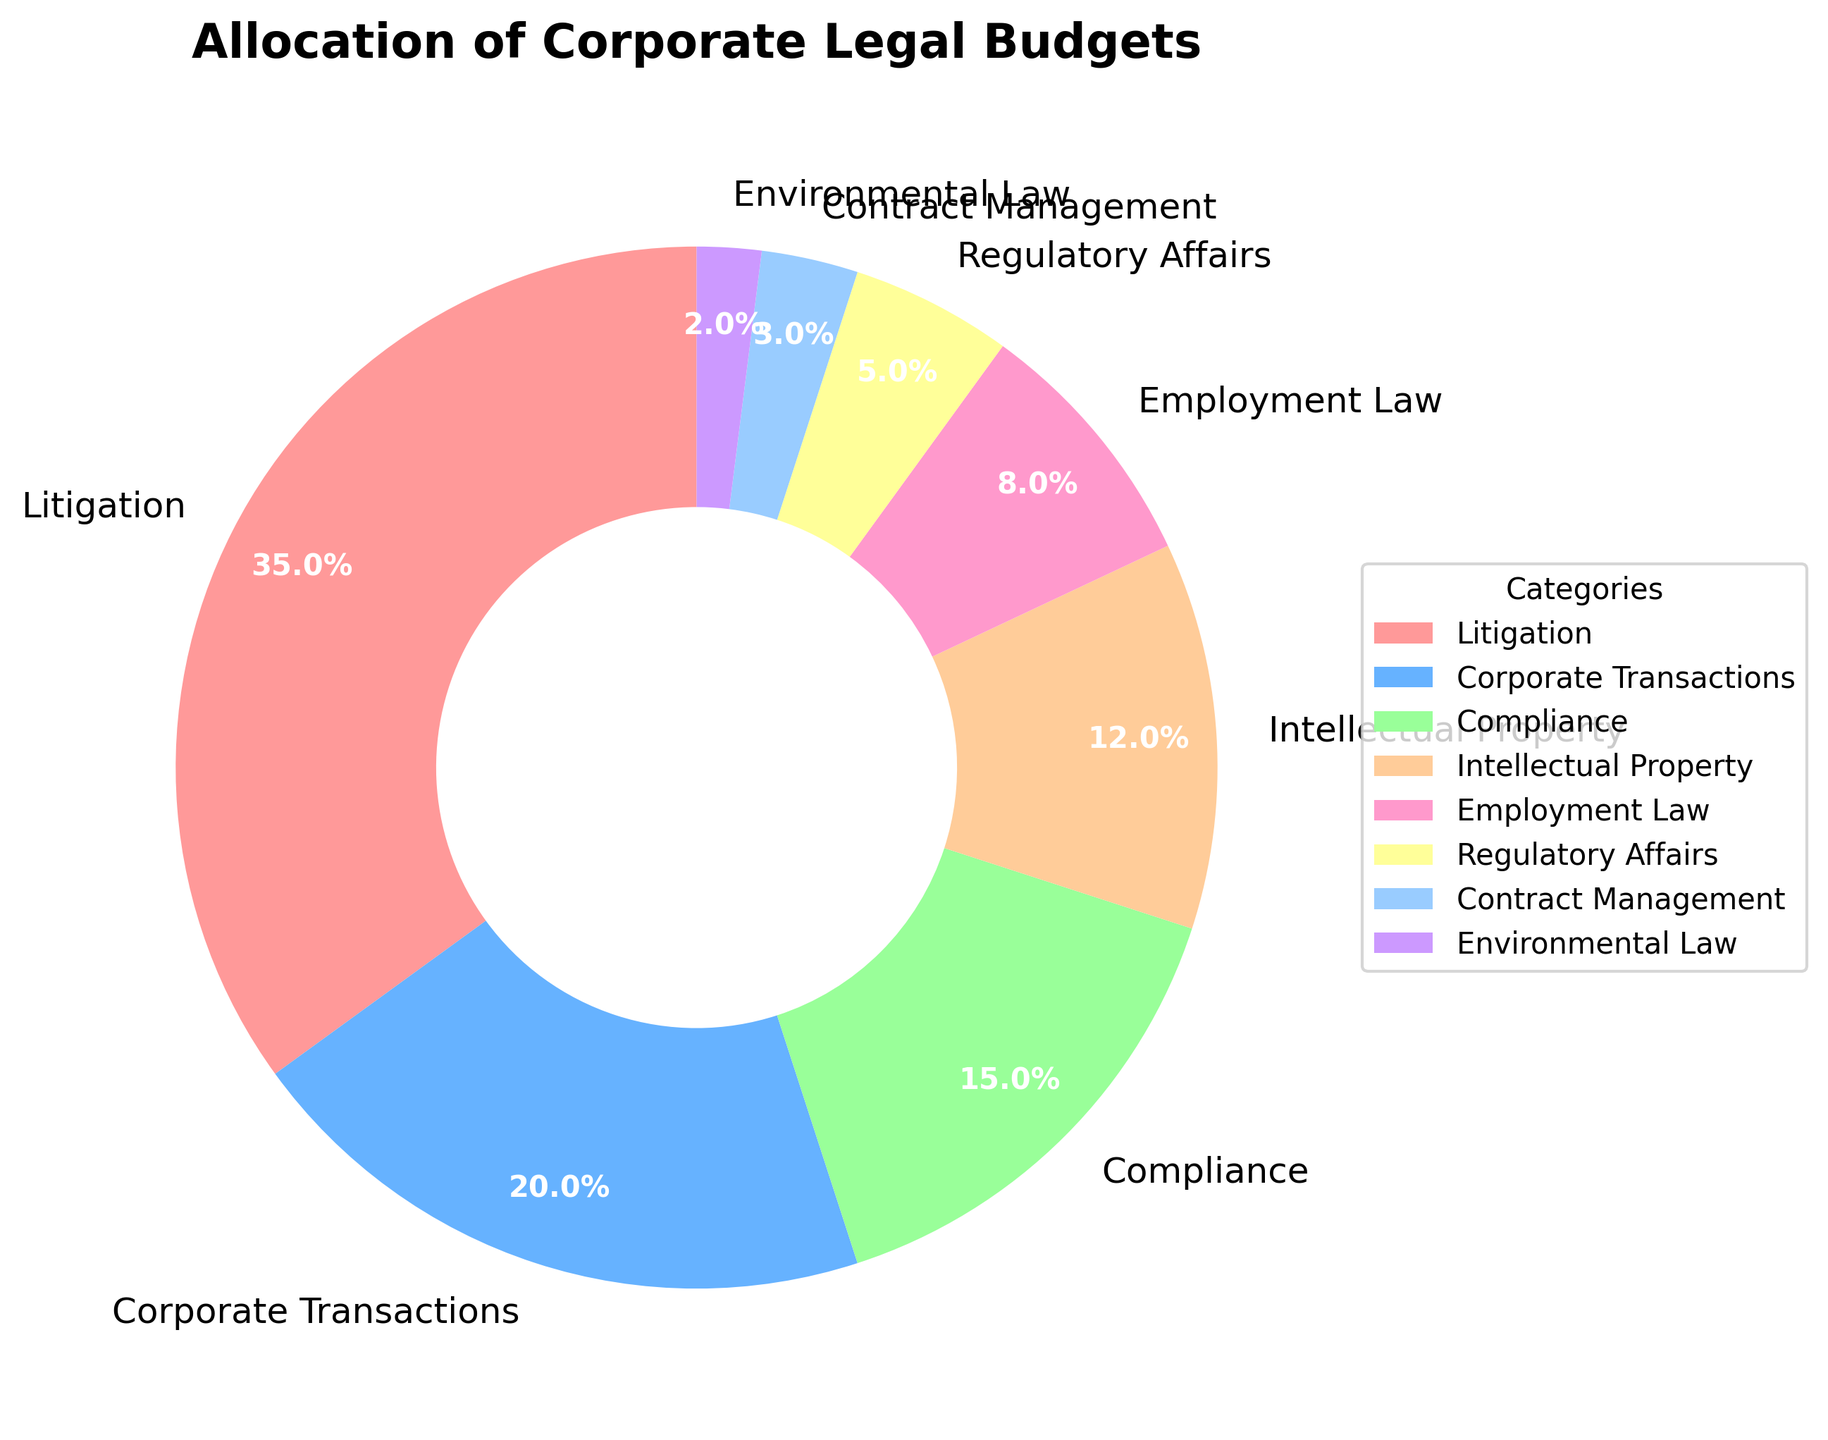What's the total percentage allocated to Litigation and Corporate Transactions together? To determine the total percentage allocated to Litigation and Corporate Transactions, add the percentages of both categories: Litigation (35%) and Corporate Transactions (20%). The sum is 35% + 20% = 55%.
Answer: 55% Which category has the least allocation, and what is its percentage? To find the category with the least allocation, look for the smallest percentage in the pie chart. Here, Environmental Law has the smallest percentage at 2%.
Answer: Environmental Law, 2% How much greater is the allocation to Litigation compared to Compliance? To find how much greater the allocation to Litigation is compared to Compliance, subtract the percentage of Compliance from the percentage of Litigation: 35% (Litigation) - 15% (Compliance) = 20%.
Answer: 20% What is the combined percentage for Employment Law, Contract Management, and Environmental Law? Add the percentages for Employment Law (8%), Contract Management (3%), and Environmental Law (2%): 8% + 3% + 2% = 13%.
Answer: 13% Which category has a larger allocation: Intellectual Property or Regulatory Affairs, and by how much? Look at the percentages for Intellectual Property (12%) and Regulatory Affairs (5%). Subtract the smaller percentage from the larger one: 12% (Intellectual Property) - 5% (Regulatory Affairs) = 7%. Intellectual Property has a larger allocation by 7%.
Answer: Intellectual Property, 7% What color represents Compliance in the pie chart? Compliance is represented by the color that occupies 15% of the pie chart. In the color list, it corresponds to the fourth color in the sequence. Therefore, Compliance is represented by a shade of yellow (#FFFF99).
Answer: Yellow If you sum the percentages of Intellectual Property, Employment Law, and Regulatory Affairs, what is their total allocation? To determine this, add the percentages of Intellectual Property (12%), Employment Law (8%), and Regulatory Affairs (5%): 12% + 8% + 5% = 25%.
Answer: 25% What is the difference in percentage allocation between the top two highest budget categories? Identify the top two categories: Litigation (35%) and Corporate Transactions (20%). Subtract the smaller from the larger: 35% - 20% = 15%.
Answer: 15% Is compliance allocated more or less than 20% of the budget? From the pie chart, Compliance is allocated 15% of the budget, which is less than 20%.
Answer: Less What is the combined allocation percentage for non-litigation categories? Subtract the percentage of Litigation from 100% because it's the only litigation category. All other categories form non-litigation: 100% - 35% = 65%.
Answer: 65% 